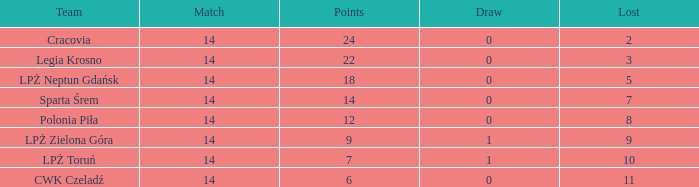What is the sum for the match with a draw less than 0? None. 